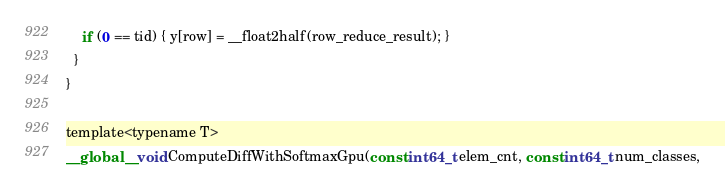Convert code to text. <code><loc_0><loc_0><loc_500><loc_500><_Cuda_>    if (0 == tid) { y[row] = __float2half(row_reduce_result); }
  }
}

template<typename T>
__global__ void ComputeDiffWithSoftmaxGpu(const int64_t elem_cnt, const int64_t num_classes,</code> 